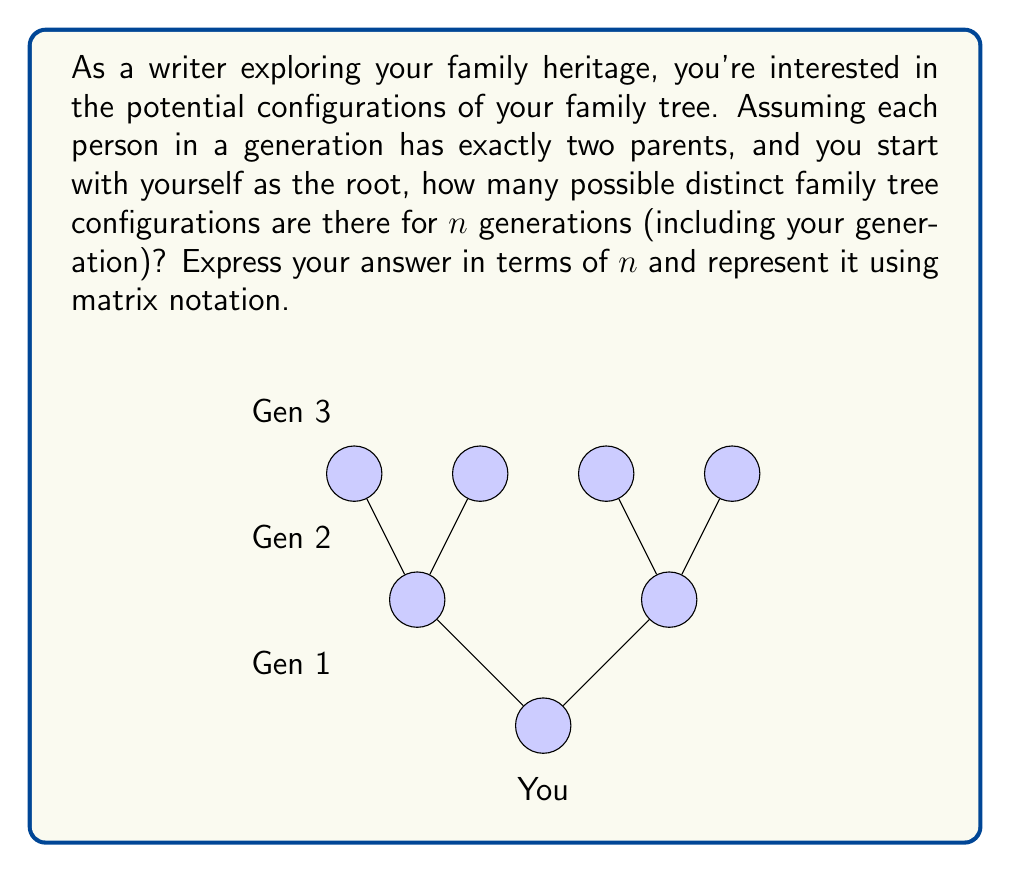Can you answer this question? Let's approach this step-by-step:

1) In each generation, every person has two parents. This creates a binary tree structure.

2) For $n$ generations, the tree has $n$ levels (including the root level).

3) In a binary tree, each node can be in one of two states: present or absent. However, in a family tree, if a node is present, all its ancestors must also be present.

4) Let's define a matrix $A$ where $A_{ij}$ represents the number of possible configurations for a subtree with $i$ levels, where the root of this subtree is at level $j$ of the full tree.

5) We can fill this matrix as follows:
   - $A_{1j} = 1$ for all $j$ (a single node has only one configuration)
   - $A_{ij} = 1 + A_{i-1,j+1}^2$ for $i > 1$
     (either the node is absent (1 configuration) or it's present with two subtrees)

6) The matrix $A$ for $n$ generations will be an $n \times n$ upper triangular matrix.

7) The element $A_{n1}$ will give us the total number of configurations for the full tree.

8) For example, for $n = 3$, the matrix $A$ would be:

   $$A = \begin{bmatrix}
   1 & 1 & 1 \\
   2 & 2 & 0 \\
   5 & 0 & 0
   \end{bmatrix}$$

9) The answer for $n = 3$ is $A_{31} = 5$.

10) For general $n$, we can express the answer as:

    $$A_{n1} = \left(\begin{bmatrix}
    1 & 1 & \cdots & 1 \\
    2 & 2 & \cdots & 0 \\
    \vdots & \vdots & \ddots & \vdots \\
    * & 0 & \cdots & 0
    \end{bmatrix}\right)_{n1}$$

    where $*$ represents the final answer and the matrix is $n \times n$.
Answer: $A_{n1}$ where $A$ is the $n \times n$ matrix defined by $A_{1j} = 1$, $A_{ij} = 1 + A_{i-1,j+1}^2$ for $i > 1$ 